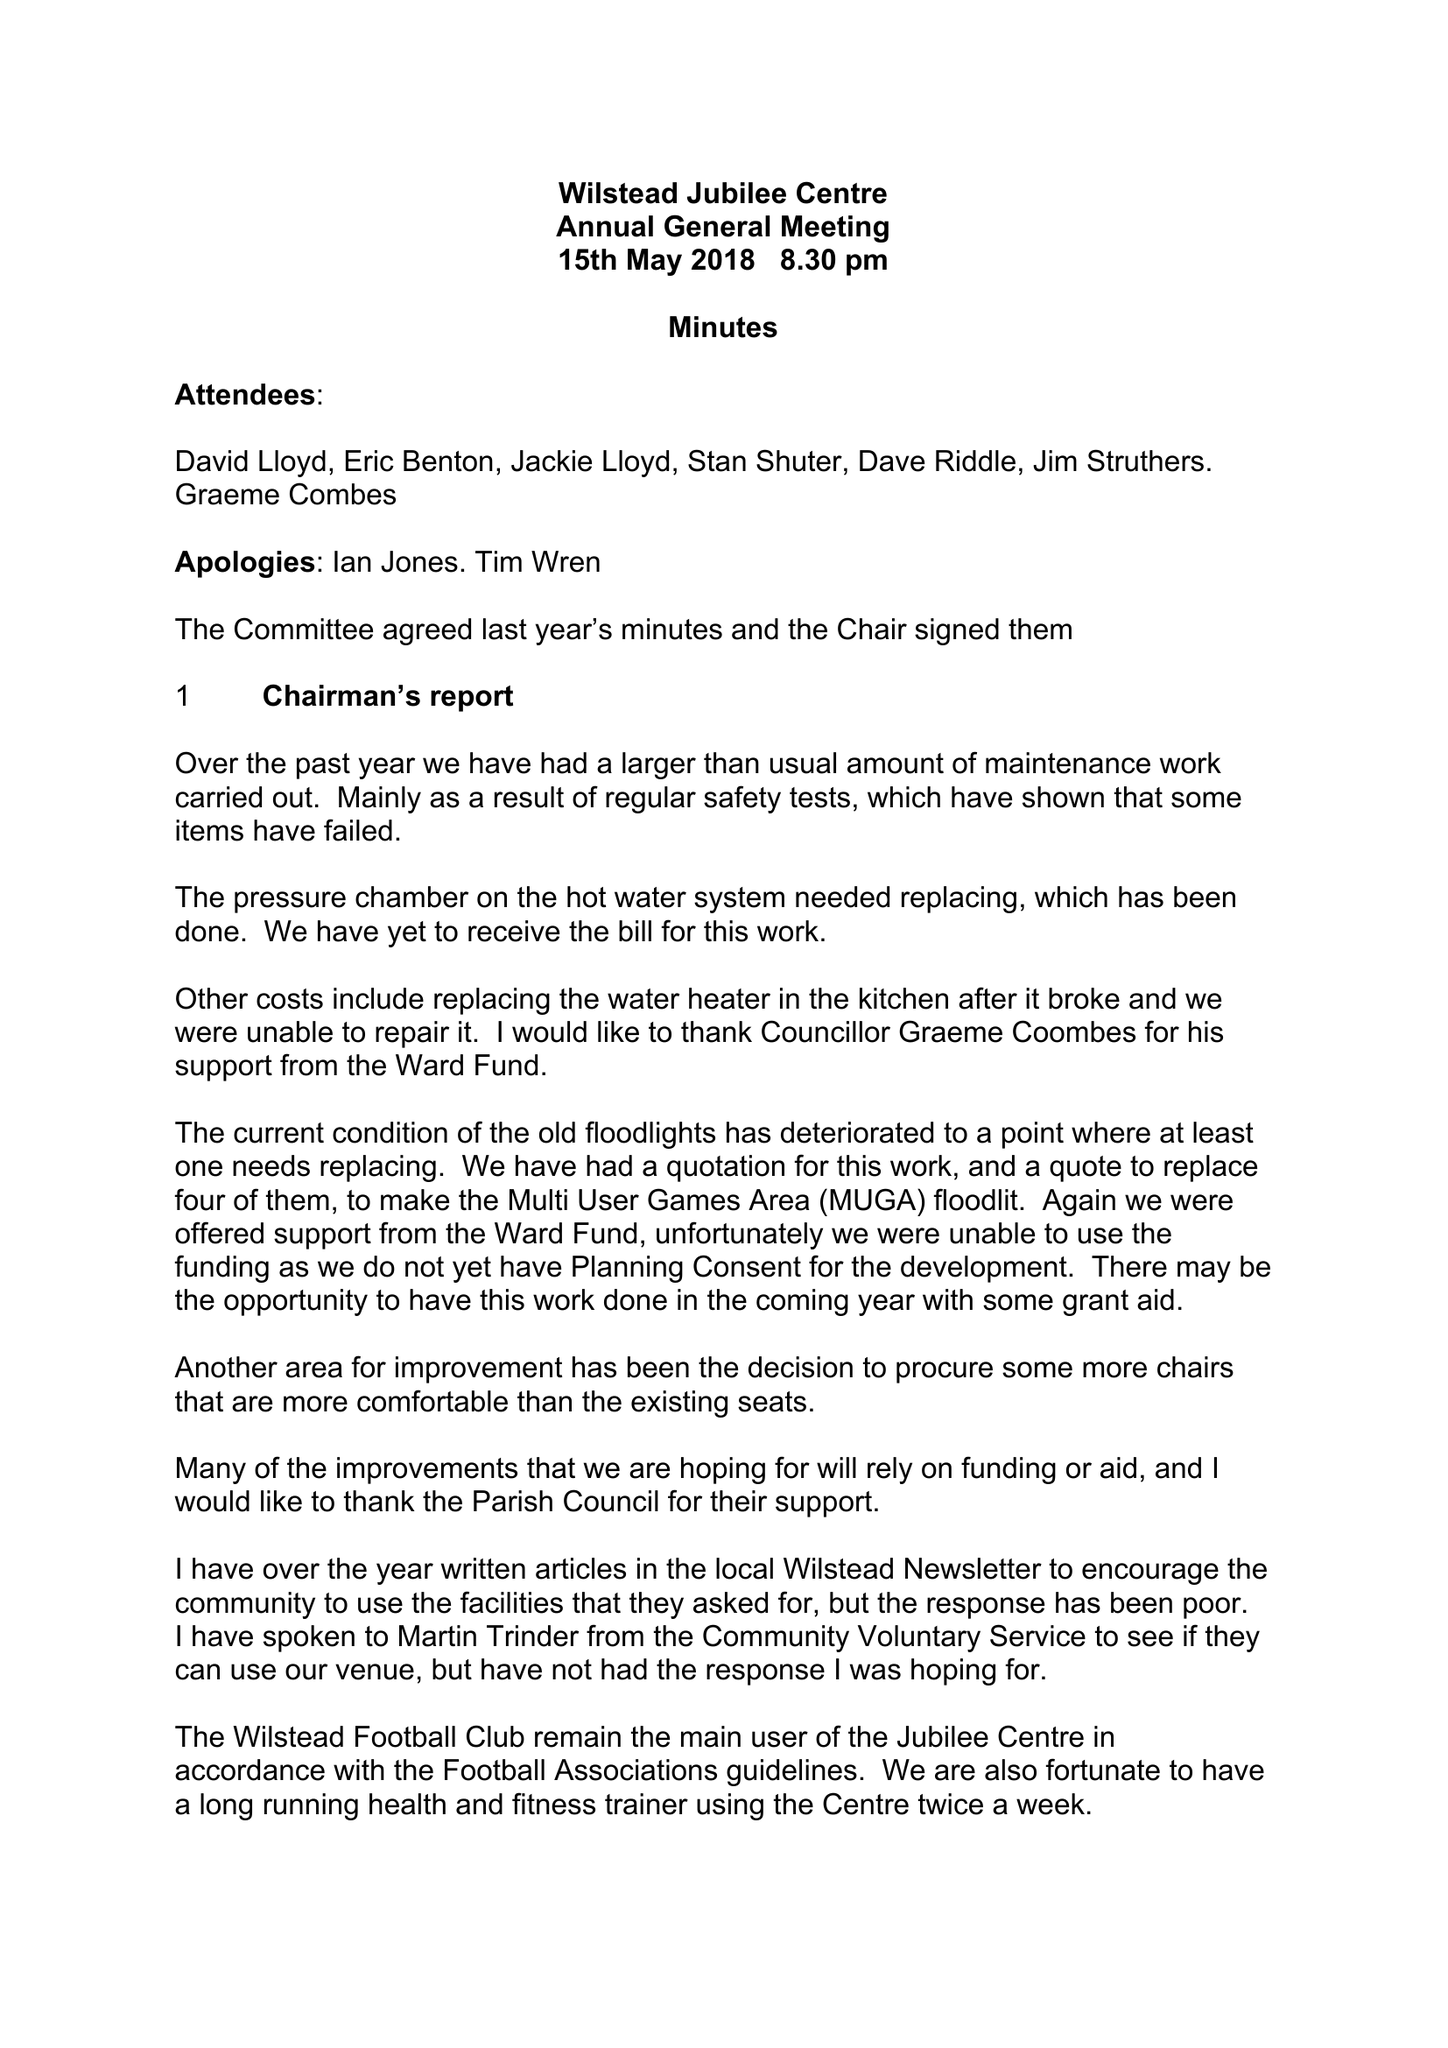What is the value for the spending_annually_in_british_pounds?
Answer the question using a single word or phrase. 5858.21 